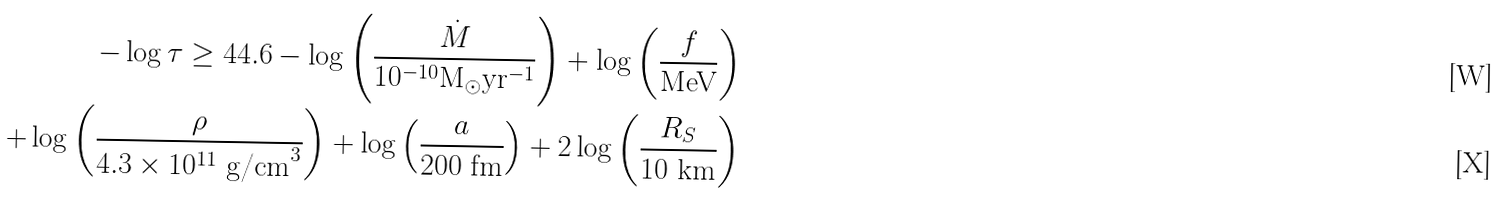Convert formula to latex. <formula><loc_0><loc_0><loc_500><loc_500>- \log \tau \geq 4 4 . 6 - \log \left ( \frac { \dot { M } } { 1 0 ^ { - 1 0 } \text {M} _ { \odot } \text {yr} ^ { - 1 } } \right ) + \log \left ( \frac { f } { \text {MeV} } \right ) \\ + \log \left ( \frac { \rho } { 4 . 3 \times 1 0 ^ { 1 1 } \text { g/cm} ^ { 3 } } \right ) + \log \left ( \frac { a } { 2 0 0 \text { fm} } \right ) + 2 \log \left ( \frac { R _ { S } } { 1 0 \text { km} } \right )</formula> 